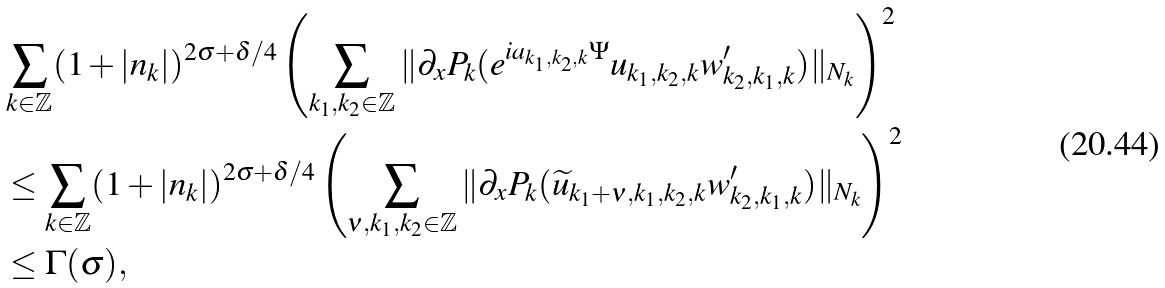Convert formula to latex. <formula><loc_0><loc_0><loc_500><loc_500>& \sum _ { k \in \mathbb { Z } } ( 1 + | n _ { k } | ) ^ { 2 \sigma + \delta / 4 } \left ( \sum _ { k _ { 1 } , k _ { 2 } \in \mathbb { Z } } \| \partial _ { x } P _ { k } ( e ^ { i a _ { k _ { 1 } , k _ { 2 } , k } \Psi } u _ { k _ { 1 } , k _ { 2 } , k } w ^ { \prime } _ { k _ { 2 } , k _ { 1 } , k } ) \| _ { N _ { k } } \right ) ^ { 2 } \\ & \leq \sum _ { k \in \mathbb { Z } } ( 1 + | n _ { k } | ) ^ { 2 \sigma + \delta / 4 } \left ( \sum _ { \nu , k _ { 1 } , k _ { 2 } \in \mathbb { Z } } \| \partial _ { x } P _ { k } ( \widetilde { u } _ { k _ { 1 } + \nu , k _ { 1 } , k _ { 2 } , k } w ^ { \prime } _ { k _ { 2 } , k _ { 1 } , k } ) \| _ { N _ { k } } \right ) ^ { 2 } \\ & \leq \Gamma ( \sigma ) ,</formula> 